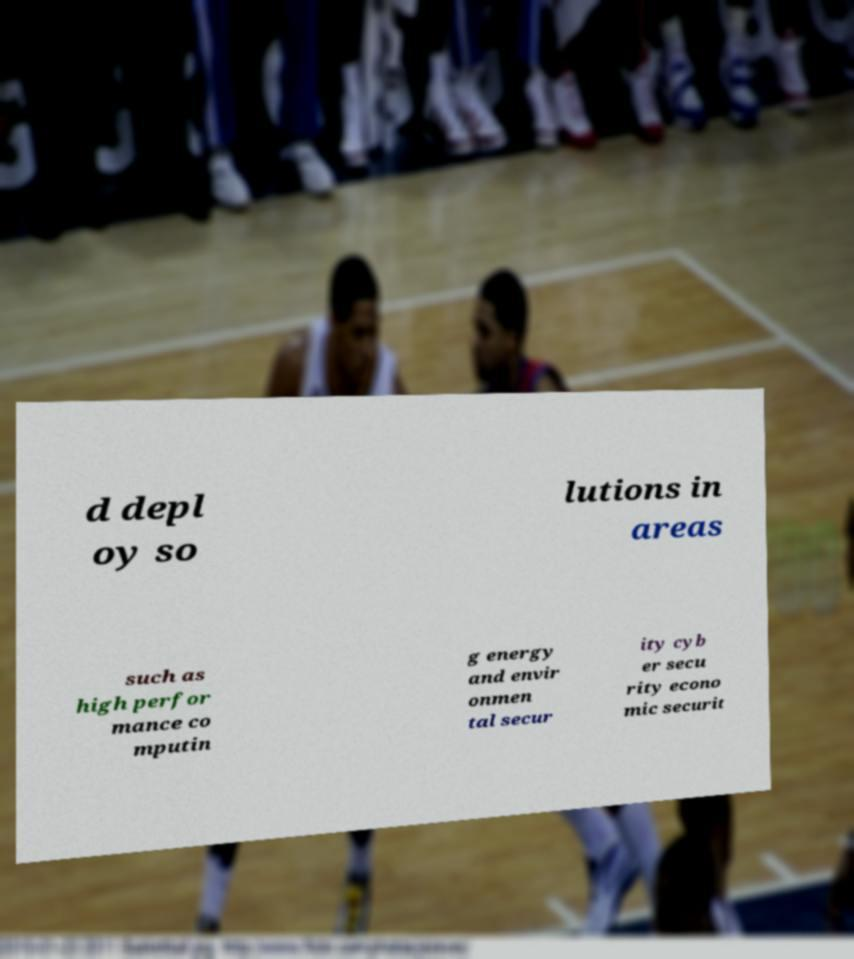For documentation purposes, I need the text within this image transcribed. Could you provide that? d depl oy so lutions in areas such as high perfor mance co mputin g energy and envir onmen tal secur ity cyb er secu rity econo mic securit 